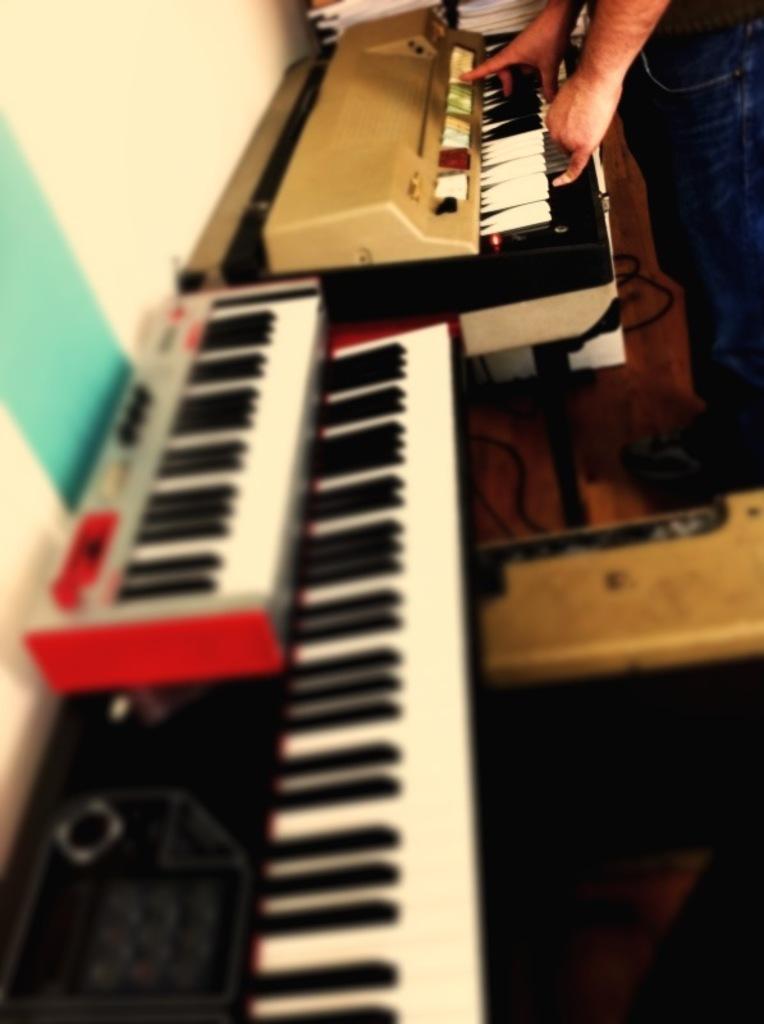In one or two sentences, can you explain what this image depicts? There are three keyboards. And in the back side one person is playing one keyboard. And there are some books kept in the background. 